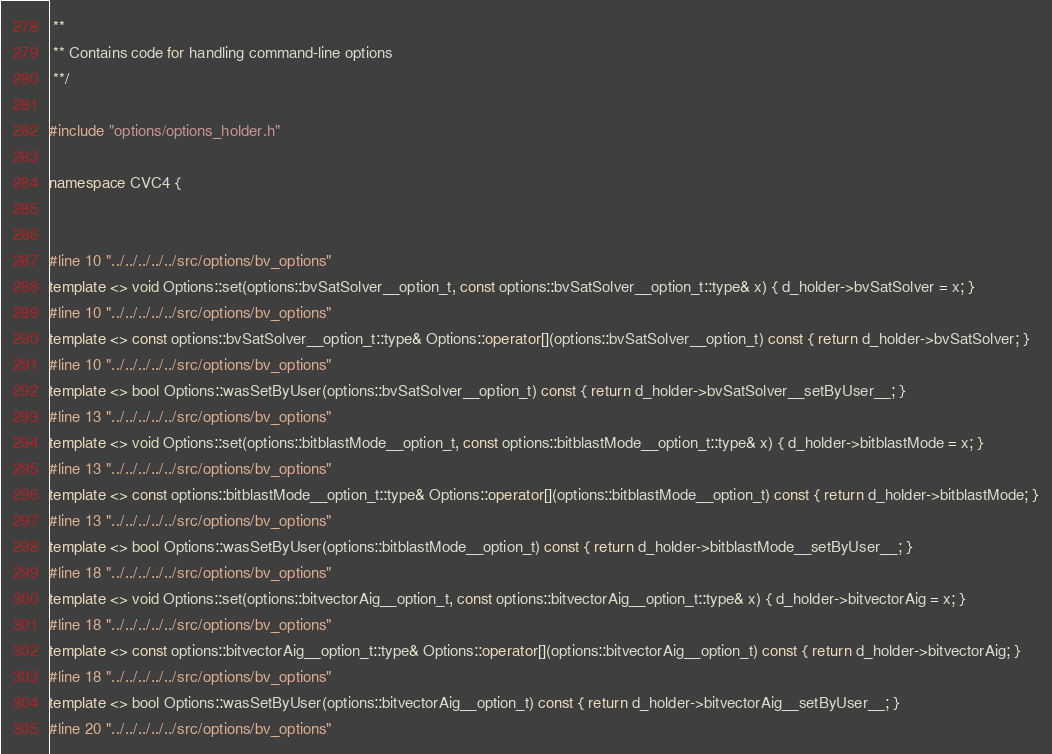<code> <loc_0><loc_0><loc_500><loc_500><_C++_> **
 ** Contains code for handling command-line options
 **/

#include "options/options_holder.h"

namespace CVC4 {


#line 10 "../../../../../src/options/bv_options"
template <> void Options::set(options::bvSatSolver__option_t, const options::bvSatSolver__option_t::type& x) { d_holder->bvSatSolver = x; }
#line 10 "../../../../../src/options/bv_options"
template <> const options::bvSatSolver__option_t::type& Options::operator[](options::bvSatSolver__option_t) const { return d_holder->bvSatSolver; }
#line 10 "../../../../../src/options/bv_options"
template <> bool Options::wasSetByUser(options::bvSatSolver__option_t) const { return d_holder->bvSatSolver__setByUser__; }
#line 13 "../../../../../src/options/bv_options"
template <> void Options::set(options::bitblastMode__option_t, const options::bitblastMode__option_t::type& x) { d_holder->bitblastMode = x; }
#line 13 "../../../../../src/options/bv_options"
template <> const options::bitblastMode__option_t::type& Options::operator[](options::bitblastMode__option_t) const { return d_holder->bitblastMode; }
#line 13 "../../../../../src/options/bv_options"
template <> bool Options::wasSetByUser(options::bitblastMode__option_t) const { return d_holder->bitblastMode__setByUser__; }
#line 18 "../../../../../src/options/bv_options"
template <> void Options::set(options::bitvectorAig__option_t, const options::bitvectorAig__option_t::type& x) { d_holder->bitvectorAig = x; }
#line 18 "../../../../../src/options/bv_options"
template <> const options::bitvectorAig__option_t::type& Options::operator[](options::bitvectorAig__option_t) const { return d_holder->bitvectorAig; }
#line 18 "../../../../../src/options/bv_options"
template <> bool Options::wasSetByUser(options::bitvectorAig__option_t) const { return d_holder->bitvectorAig__setByUser__; }
#line 20 "../../../../../src/options/bv_options"</code> 